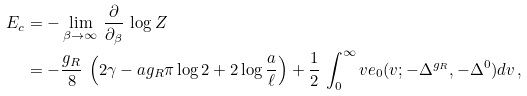<formula> <loc_0><loc_0><loc_500><loc_500>E _ { c } & = - \lim _ { \beta \to \infty } \, \frac { \partial } { \partial _ { \beta } } \, \log Z \\ & = - \frac { g _ { R } } { 8 } \, \left ( 2 \gamma - a g _ { R } \pi \log 2 + 2 \log \frac { a } { \ell } \right ) + \frac { 1 } { 2 } \, \int _ { 0 } ^ { \infty } v e _ { 0 } ( v ; - \Delta ^ { g _ { R } } , - \Delta ^ { 0 } ) d v \, ,</formula> 